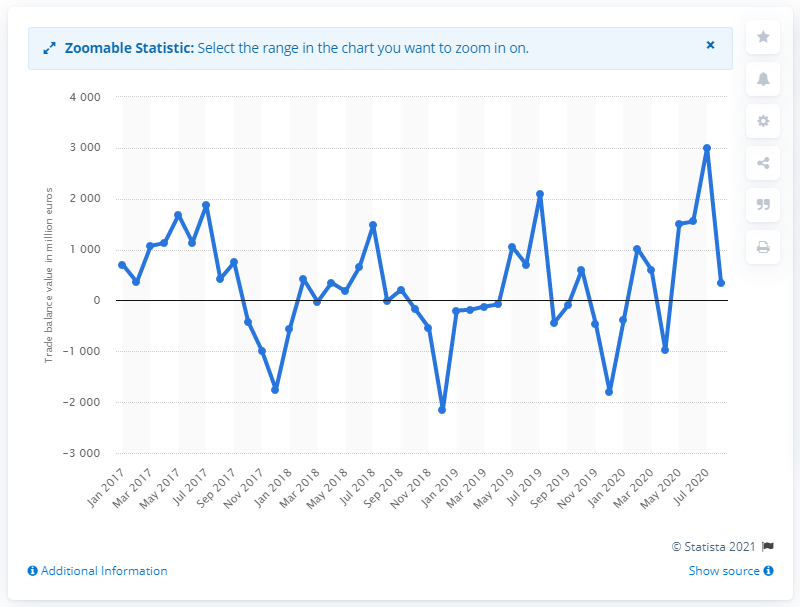Indicate a few pertinent items in this graphic. In August of 2020, Italy's trade balance with the European Union was 348 million. 